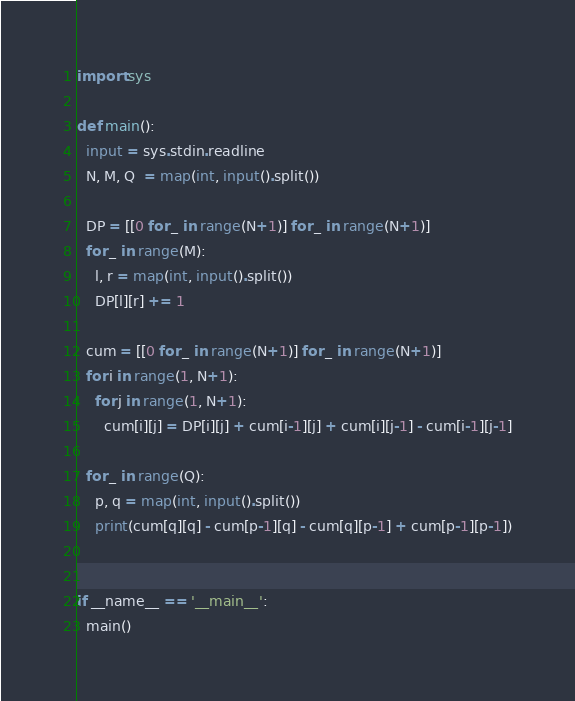Convert code to text. <code><loc_0><loc_0><loc_500><loc_500><_Python_>import sys

def main():
  input = sys.stdin.readline
  N, M, Q  = map(int, input().split())
  
  DP = [[0 for _ in range(N+1)] for _ in range(N+1)] 
  for _ in range(M):
    l, r = map(int, input().split())
    DP[l][r] += 1

  cum = [[0 for _ in range(N+1)] for _ in range(N+1)]
  for i in range(1, N+1):
    for j in range(1, N+1):
      cum[i][j] = DP[i][j] + cum[i-1][j] + cum[i][j-1] - cum[i-1][j-1]

  for _ in range(Q):
    p, q = map(int, input().split())
    print(cum[q][q] - cum[p-1][q] - cum[q][p-1] + cum[p-1][p-1])


if __name__ == '__main__':
  main()</code> 